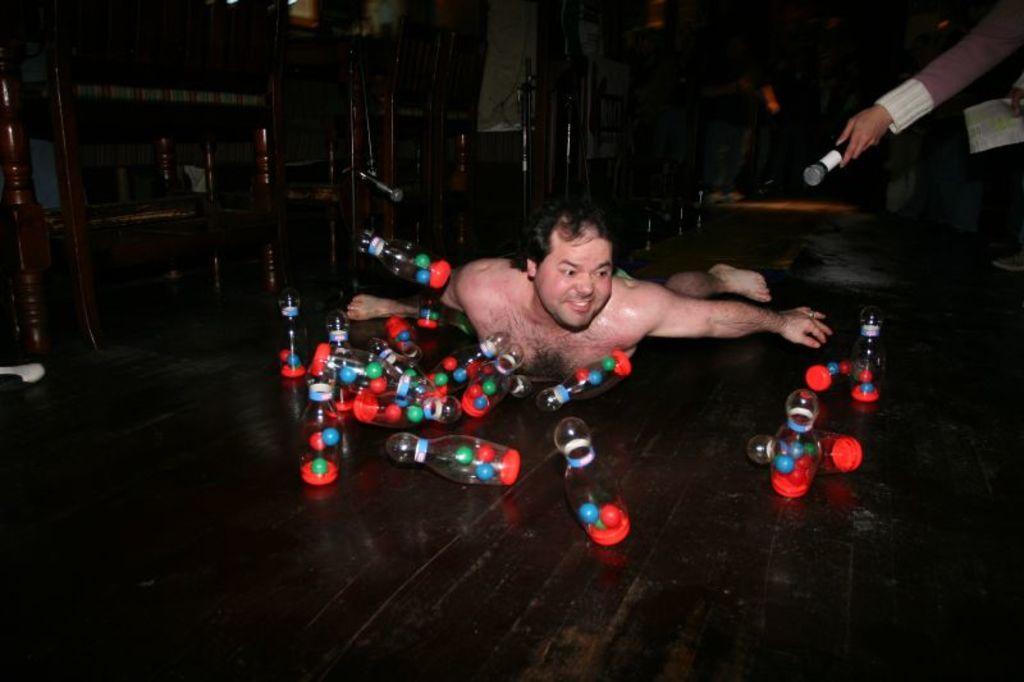Describe this image in one or two sentences. In this image we can see a person lying down on the floor. We can also see some bottles with balls inside them placed around him. On the right side we can see the hand of a person holding some papers and a mic. On the left side we can see some wooden tables. 